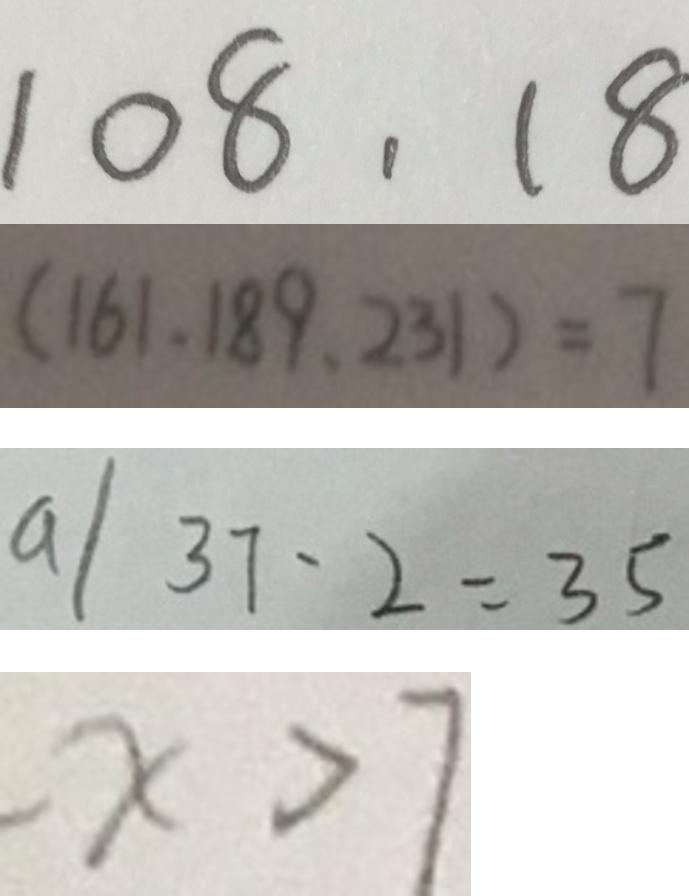Convert formula to latex. <formula><loc_0><loc_0><loc_500><loc_500>1 0 8 , 1 8 
 ( 1 6 1 , 1 8 9 , 2 3 1 ) = 7 
 a / 3 7 - 2 = 3 5 
 - x > 7</formula> 